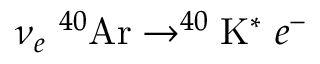<formula> <loc_0><loc_0><loc_500><loc_500>\nu _ { e } \ ^ { 4 0 } A r \rightarrow ^ { 4 0 } K ^ { * } \ e ^ { - }</formula> 